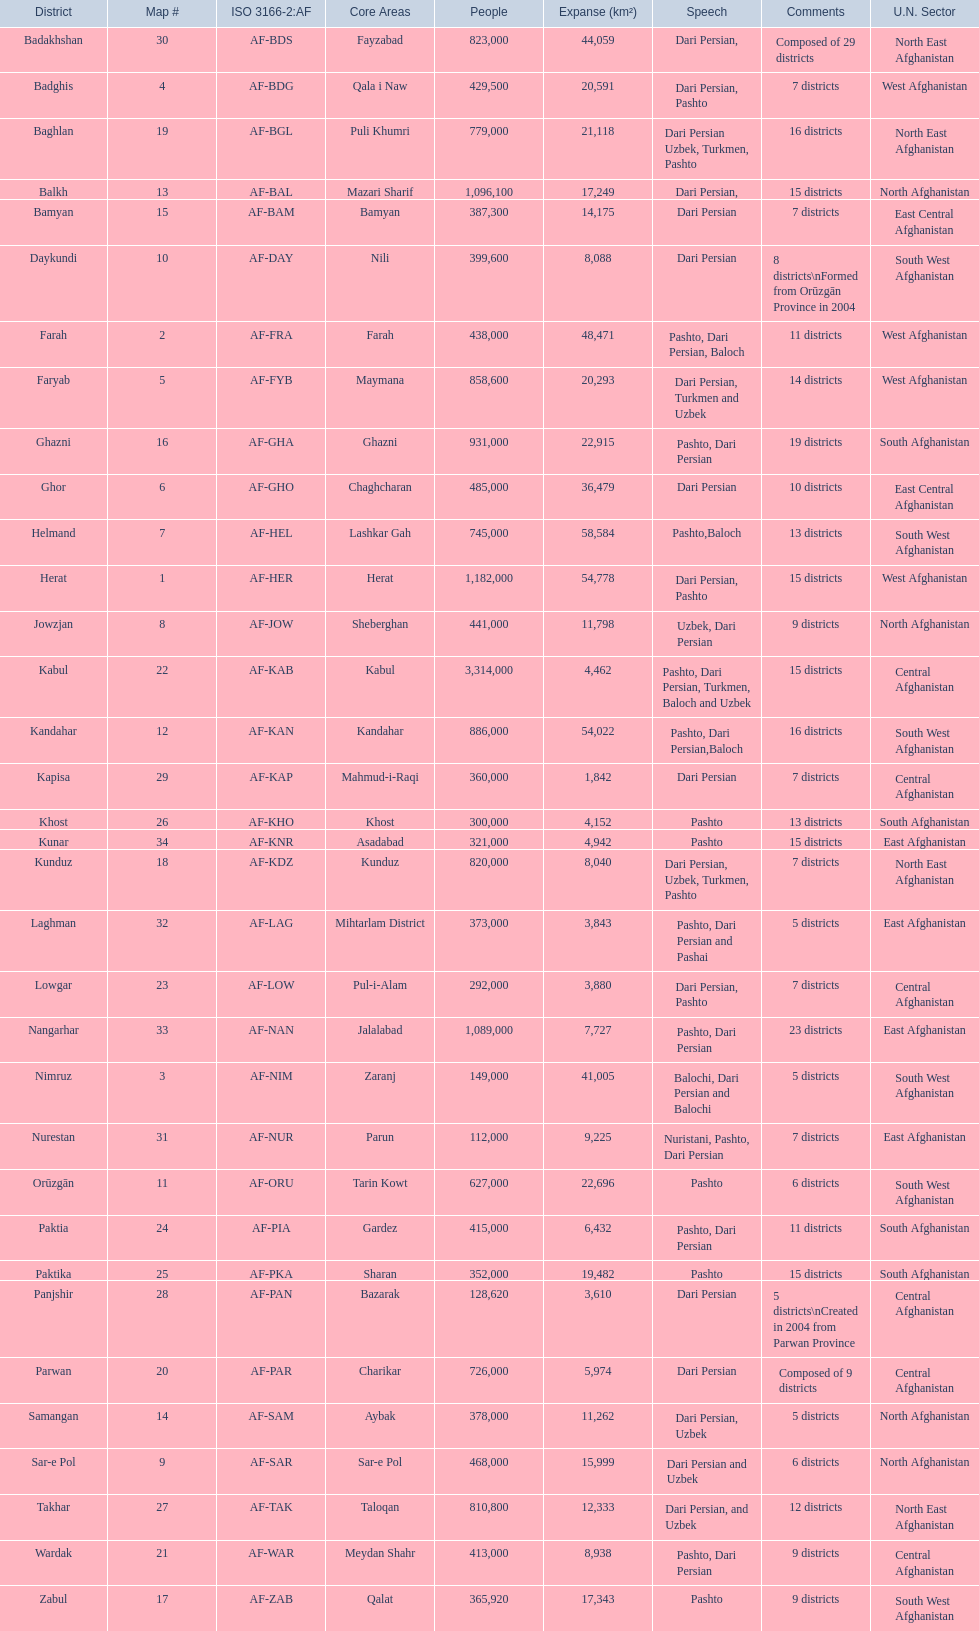What is the number of districts in the kunduz province? 7. 